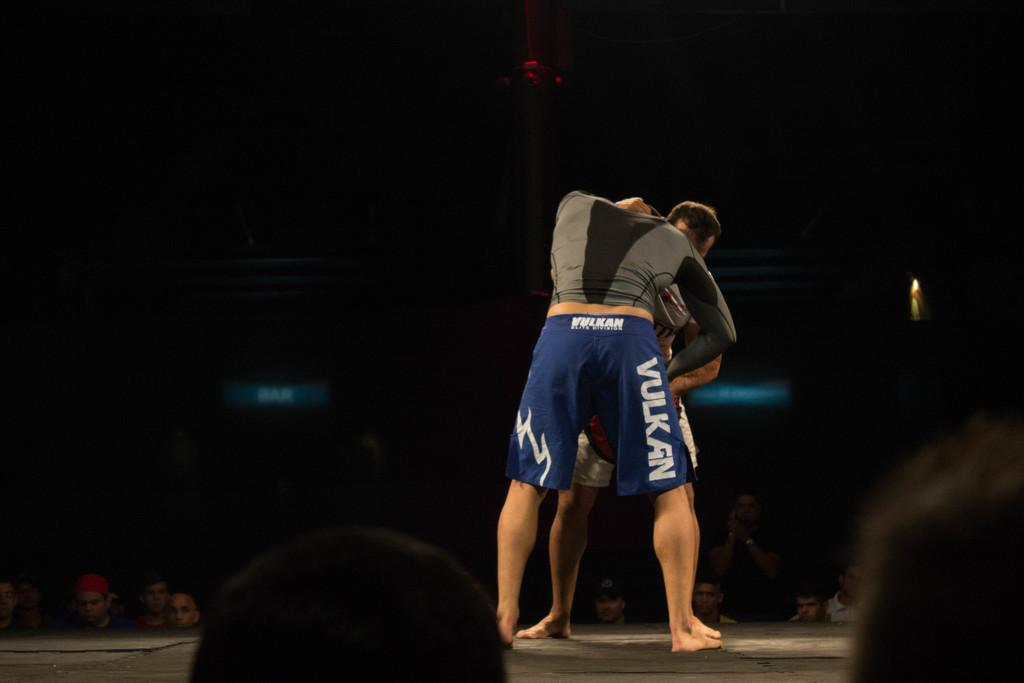Provide a one-sentence caption for the provided image. A man in blue, boxing shorts that say Vulkan on the side is trying to pin another man in front of him, while standing. 